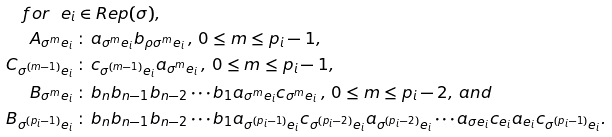Convert formula to latex. <formula><loc_0><loc_0><loc_500><loc_500>f o r \ e _ { i } & \in R e p ( \sigma ) , \\ A _ { \sigma ^ { m } e _ { i } } \, & \colon \, a _ { \sigma ^ { m } e _ { i } } b _ { \rho \sigma ^ { m } e _ { i } } \, , \, 0 \leq m \leq p _ { i } - 1 , \\ C _ { \sigma ^ { ( m - 1 ) } e _ { i } } \, & \colon \, c _ { \sigma ^ { ( m - 1 ) } e _ { i } } a _ { \sigma ^ { m } e _ { i } } \, , \, 0 \leq m \leq p _ { i } - 1 , \\ B _ { \sigma ^ { m } e _ { i } } \, & \colon \, b _ { n } b _ { n - 1 } b _ { n - 2 } \cdots b _ { 1 } a _ { \sigma ^ { m } e _ { i } } c _ { \sigma ^ { m } e _ { i } } \, , \, 0 \leq m \leq p _ { i } - 2 , \, a n d \\ B _ { \sigma ^ { ( p _ { i } - 1 ) } e _ { i } } \, & \colon \, b _ { n } b _ { n - 1 } b _ { n - 2 } \cdots b _ { 1 } a _ { \sigma ^ { ( p _ { i } - 1 ) } e _ { i } } c _ { \sigma ^ { ( p _ { i } - 2 ) } e _ { i } } a _ { \sigma ^ { ( p _ { i } - 2 ) } e _ { i } } \cdots a _ { \sigma e _ { i } } c _ { e _ { i } } a _ { e _ { i } } c _ { \sigma ^ { ( p _ { i } - 1 ) } e _ { i } } .</formula> 